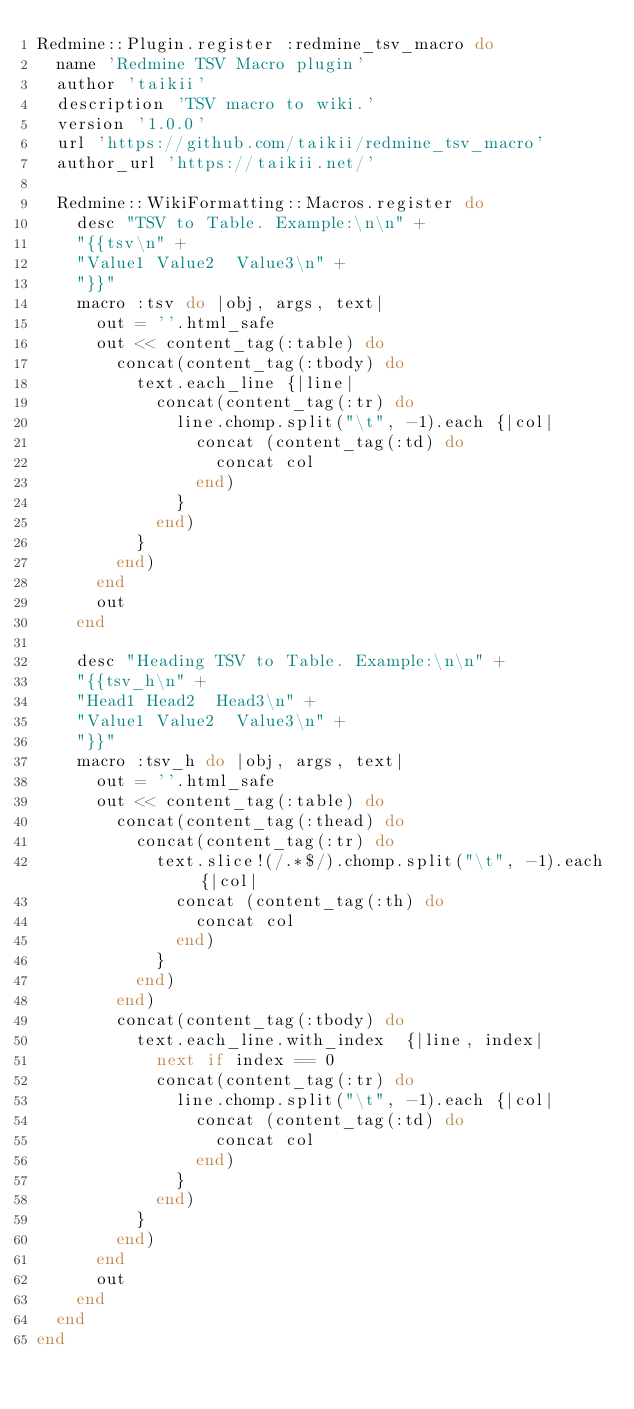Convert code to text. <code><loc_0><loc_0><loc_500><loc_500><_Ruby_>Redmine::Plugin.register :redmine_tsv_macro do
  name 'Redmine TSV Macro plugin'
  author 'taikii'
  description 'TSV macro to wiki.'
  version '1.0.0'
  url 'https://github.com/taikii/redmine_tsv_macro'
  author_url 'https://taikii.net/'

  Redmine::WikiFormatting::Macros.register do
    desc "TSV to Table. Example:\n\n" +
    "{{tsv\n" +
    "Value1 Value2  Value3\n" +
    "}}"
    macro :tsv do |obj, args, text|
      out = ''.html_safe
      out << content_tag(:table) do
        concat(content_tag(:tbody) do
          text.each_line {|line|
            concat(content_tag(:tr) do
              line.chomp.split("\t", -1).each {|col|
                concat (content_tag(:td) do
                  concat col
                end)
              }
            end)
          }
        end)
      end
      out
    end

    desc "Heading TSV to Table. Example:\n\n" +
    "{{tsv_h\n" +
    "Head1 Head2  Head3\n" +
    "Value1 Value2  Value3\n" +
    "}}"
    macro :tsv_h do |obj, args, text|
      out = ''.html_safe
      out << content_tag(:table) do
        concat(content_tag(:thead) do
          concat(content_tag(:tr) do
            text.slice!(/.*$/).chomp.split("\t", -1).each {|col|
              concat (content_tag(:th) do
                concat col
              end)
            }
          end)
        end)
        concat(content_tag(:tbody) do
          text.each_line.with_index  {|line, index|
            next if index == 0
            concat(content_tag(:tr) do
              line.chomp.split("\t", -1).each {|col|
                concat (content_tag(:td) do
                  concat col
                end)
              }
            end)
          }
        end)
      end
      out
    end
  end
end
</code> 